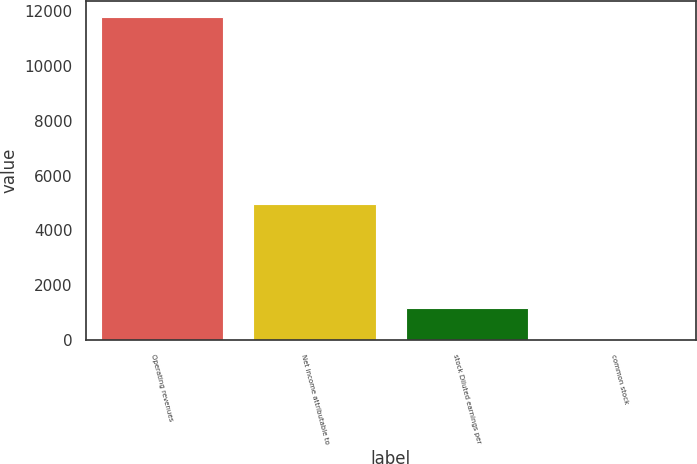<chart> <loc_0><loc_0><loc_500><loc_500><bar_chart><fcel>Operating revenues<fcel>Net income attributable to<fcel>stock Diluted earnings per<fcel>common stock<nl><fcel>11778<fcel>4980<fcel>1184.63<fcel>7.59<nl></chart> 